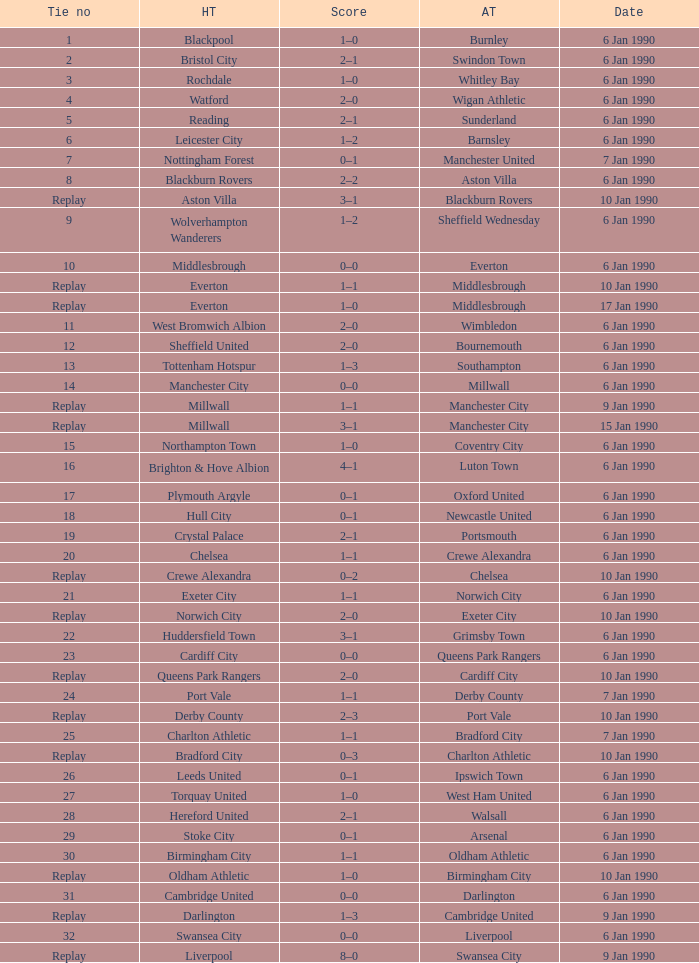What is the score of the game against away team exeter city on 10 jan 1990? 2–0. 